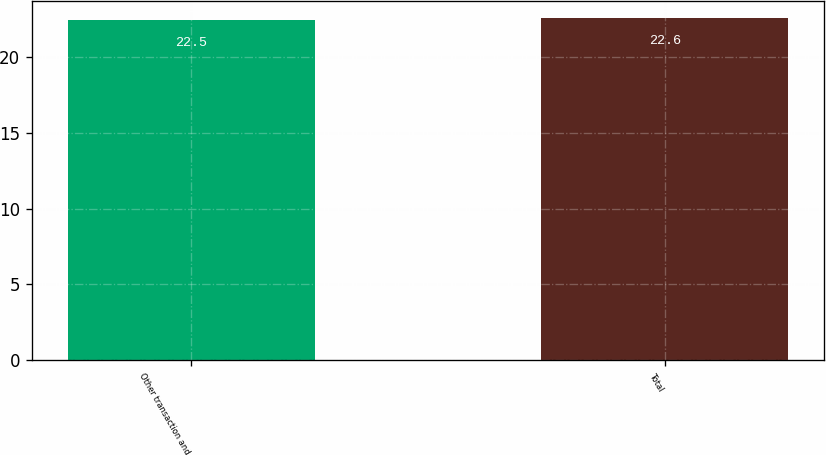<chart> <loc_0><loc_0><loc_500><loc_500><bar_chart><fcel>Other transaction and<fcel>Total<nl><fcel>22.5<fcel>22.6<nl></chart> 